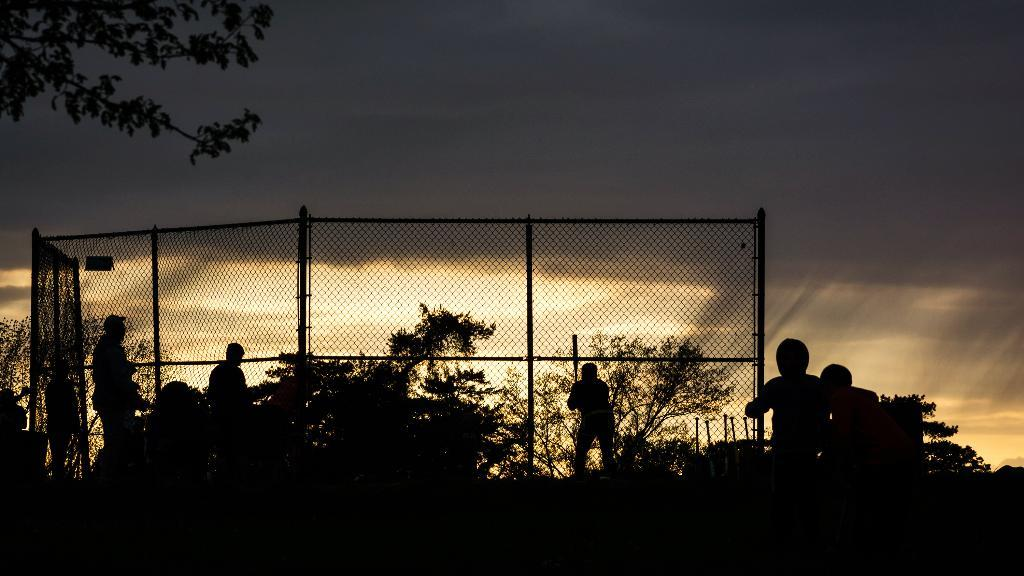What can be seen in the image? There are people standing in the image. Where are the people located in relation to the fencing wall? The people are behind a fencing wall. What type of natural environment is visible in the image? There are trees visible in the image. What part of the natural environment is visible in the image? The sky is visible in the image. What type of theory is being discussed by the people in the image? There is no indication in the image that the people are discussing any theories. 